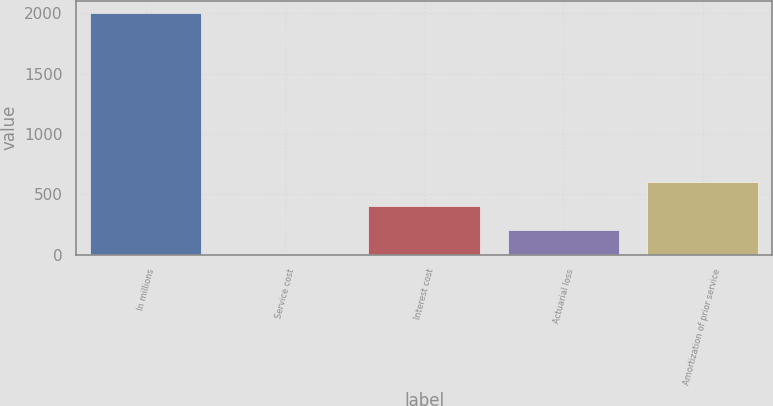Convert chart to OTSL. <chart><loc_0><loc_0><loc_500><loc_500><bar_chart><fcel>In millions<fcel>Service cost<fcel>Interest cost<fcel>Actuarial loss<fcel>Amortization of prior service<nl><fcel>2006<fcel>2<fcel>402.8<fcel>202.4<fcel>603.2<nl></chart> 